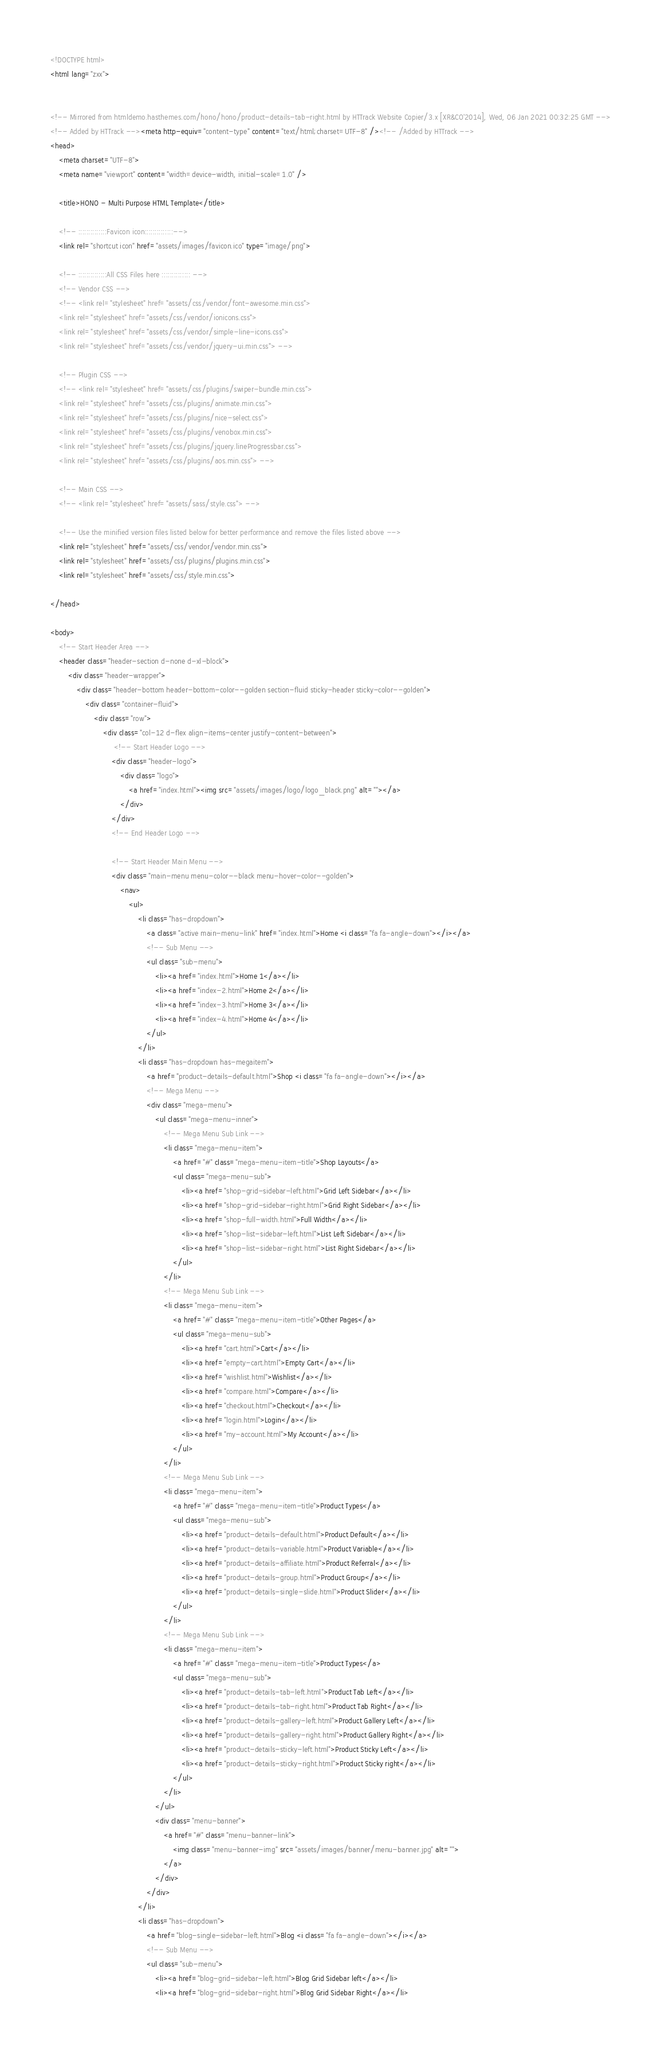Convert code to text. <code><loc_0><loc_0><loc_500><loc_500><_HTML_><!DOCTYPE html>
<html lang="zxx">


<!-- Mirrored from htmldemo.hasthemes.com/hono/hono/product-details-tab-right.html by HTTrack Website Copier/3.x [XR&CO'2014], Wed, 06 Jan 2021 00:32:25 GMT -->
<!-- Added by HTTrack --><meta http-equiv="content-type" content="text/html;charset=UTF-8" /><!-- /Added by HTTrack -->
<head>
    <meta charset="UTF-8">
    <meta name="viewport" content="width=device-width, initial-scale=1.0" />

    <title>HONO - Multi Purpose HTML Template</title>

    <!-- ::::::::::::::Favicon icon::::::::::::::-->
    <link rel="shortcut icon" href="assets/images/favicon.ico" type="image/png">

    <!-- ::::::::::::::All CSS Files here :::::::::::::: -->
    <!-- Vendor CSS -->
    <!-- <link rel="stylesheet" href="assets/css/vendor/font-awesome.min.css">
    <link rel="stylesheet" href="assets/css/vendor/ionicons.css">
    <link rel="stylesheet" href="assets/css/vendor/simple-line-icons.css">
    <link rel="stylesheet" href="assets/css/vendor/jquery-ui.min.css"> -->

    <!-- Plugin CSS -->
    <!-- <link rel="stylesheet" href="assets/css/plugins/swiper-bundle.min.css">
    <link rel="stylesheet" href="assets/css/plugins/animate.min.css">
    <link rel="stylesheet" href="assets/css/plugins/nice-select.css">
    <link rel="stylesheet" href="assets/css/plugins/venobox.min.css">
    <link rel="stylesheet" href="assets/css/plugins/jquery.lineProgressbar.css">
    <link rel="stylesheet" href="assets/css/plugins/aos.min.css"> -->

    <!-- Main CSS -->
    <!-- <link rel="stylesheet" href="assets/sass/style.css"> -->

    <!-- Use the minified version files listed below for better performance and remove the files listed above -->
    <link rel="stylesheet" href="assets/css/vendor/vendor.min.css">
    <link rel="stylesheet" href="assets/css/plugins/plugins.min.css">
    <link rel="stylesheet" href="assets/css/style.min.css">

</head>

<body>
    <!-- Start Header Area -->
    <header class="header-section d-none d-xl-block">
        <div class="header-wrapper">
            <div class="header-bottom header-bottom-color--golden section-fluid sticky-header sticky-color--golden">
                <div class="container-fluid">
                    <div class="row">
                        <div class="col-12 d-flex align-items-center justify-content-between">
                             <!-- Start Header Logo -->
                            <div class="header-logo">
                                <div class="logo">
                                    <a href="index.html"><img src="assets/images/logo/logo_black.png" alt=""></a>
                                </div>
                            </div>
                            <!-- End Header Logo -->

                            <!-- Start Header Main Menu -->
                            <div class="main-menu menu-color--black menu-hover-color--golden">
                                <nav>
                                    <ul>
                                        <li class="has-dropdown">
                                            <a class="active main-menu-link" href="index.html">Home <i class="fa fa-angle-down"></i></a>
                                            <!-- Sub Menu -->
                                            <ul class="sub-menu">
                                                <li><a href="index.html">Home 1</a></li>
                                                <li><a href="index-2.html">Home 2</a></li>
                                                <li><a href="index-3.html">Home 3</a></li>
                                                <li><a href="index-4.html">Home 4</a></li>
                                            </ul>
                                        </li>
                                        <li class="has-dropdown has-megaitem">
                                            <a href="product-details-default.html">Shop <i class="fa fa-angle-down"></i></a>
                                            <!-- Mega Menu -->
                                            <div class="mega-menu">
                                                <ul class="mega-menu-inner">
                                                    <!-- Mega Menu Sub Link -->
                                                    <li class="mega-menu-item">
                                                        <a href="#" class="mega-menu-item-title">Shop Layouts</a>
                                                        <ul class="mega-menu-sub">
                                                            <li><a href="shop-grid-sidebar-left.html">Grid Left Sidebar</a></li>
                                                            <li><a href="shop-grid-sidebar-right.html">Grid Right Sidebar</a></li>
                                                            <li><a href="shop-full-width.html">Full Width</a></li>
                                                            <li><a href="shop-list-sidebar-left.html">List Left Sidebar</a></li>
                                                            <li><a href="shop-list-sidebar-right.html">List Right Sidebar</a></li>
                                                        </ul>
                                                    </li>
                                                    <!-- Mega Menu Sub Link -->
                                                    <li class="mega-menu-item">
                                                        <a href="#" class="mega-menu-item-title">Other Pages</a>
                                                        <ul class="mega-menu-sub">
                                                            <li><a href="cart.html">Cart</a></li>
                                                            <li><a href="empty-cart.html">Empty Cart</a></li>
                                                            <li><a href="wishlist.html">Wishlist</a></li>
                                                            <li><a href="compare.html">Compare</a></li>
                                                            <li><a href="checkout.html">Checkout</a></li>
                                                            <li><a href="login.html">Login</a></li>
                                                            <li><a href="my-account.html">My Account</a></li>
                                                        </ul>
                                                    </li>
                                                    <!-- Mega Menu Sub Link -->
                                                    <li class="mega-menu-item">
                                                        <a href="#" class="mega-menu-item-title">Product Types</a>
                                                        <ul class="mega-menu-sub">
                                                            <li><a href="product-details-default.html">Product Default</a></li>
                                                            <li><a href="product-details-variable.html">Product Variable</a></li>
                                                            <li><a href="product-details-affiliate.html">Product Referral</a></li>
                                                            <li><a href="product-details-group.html">Product Group</a></li>
                                                            <li><a href="product-details-single-slide.html">Product Slider</a></li>
                                                        </ul>
                                                    </li>
                                                    <!-- Mega Menu Sub Link -->
                                                    <li class="mega-menu-item">
                                                        <a href="#" class="mega-menu-item-title">Product Types</a>
                                                        <ul class="mega-menu-sub">
                                                            <li><a href="product-details-tab-left.html">Product Tab Left</a></li>
                                                            <li><a href="product-details-tab-right.html">Product Tab Right</a></li>
                                                            <li><a href="product-details-gallery-left.html">Product Gallery Left</a></li>
                                                            <li><a href="product-details-gallery-right.html">Product Gallery Right</a></li>
                                                            <li><a href="product-details-sticky-left.html">Product Sticky Left</a></li>
                                                            <li><a href="product-details-sticky-right.html">Product Sticky right</a></li>
                                                        </ul>
                                                    </li>
                                                </ul>
                                                <div class="menu-banner">
                                                    <a href="#" class="menu-banner-link">
                                                        <img class="menu-banner-img" src="assets/images/banner/menu-banner.jpg" alt="">
                                                    </a>
                                                </div>
                                            </div>
                                        </li>
                                        <li class="has-dropdown">
                                            <a href="blog-single-sidebar-left.html">Blog <i class="fa fa-angle-down"></i></a>
                                            <!-- Sub Menu -->
                                            <ul class="sub-menu">
                                                <li><a href="blog-grid-sidebar-left.html">Blog Grid Sidebar left</a></li>
                                                <li><a href="blog-grid-sidebar-right.html">Blog Grid Sidebar Right</a></li></code> 